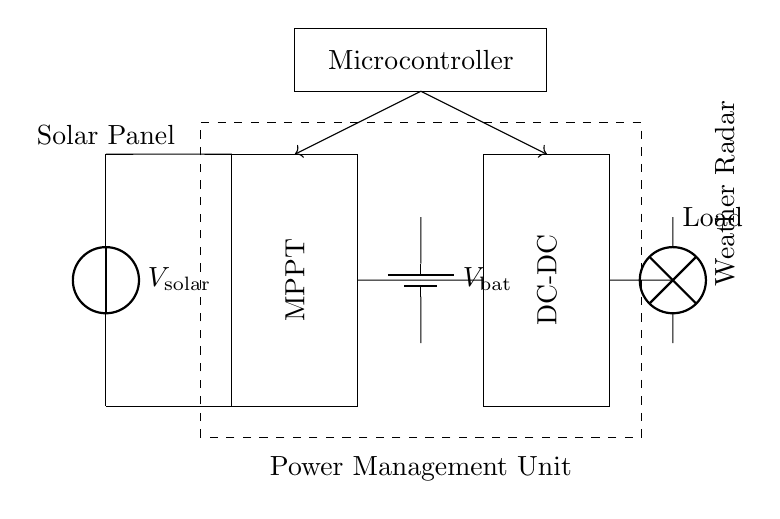What is the primary voltage source in this circuit? The primary voltage source is the solar panel, which is denoted as V_solar in the circuit. It converts sunlight into electrical energy to charge the battery.
Answer: V_solar What component manages the power flow from the solar panel? The component that manages the power flow from the solar panel is the MPPT, which stands for Maximum Power Point Tracking. It optimizes the energy harvested from the solar panel by adjusting the electrical operating point.
Answer: MPPT How many energy storage components are present in this circuit? The circuit contains one energy storage component, which is the battery labeled as V_bat. It stores energy for later use in the weather radar system.
Answer: One What is the role of the microcontroller in this circuit? The microcontroller's role is to control and manage the system's operations, including coordinating the solar panel, battery, and load based on the environmental conditions and power requirements.
Answer: Control What type of converter is used between the battery and the load? The type of converter used between the battery and the load is a DC-DC converter. This component steps up or steps down the voltage as necessary to ensure the weather radar receives the appropriate power level.
Answer: DC-DC Which element provides energy to the weather radar? The element that provides energy to the weather radar is the battery, which supplies stored electrical energy through the DC-DC converter and then to the load.
Answer: Battery What are the control lines used for in this circuit? The control lines, indicated by arrows from the microcontroller, are used for transmitting signals to control the operation of the MPPT and DC-DC converter to ensure efficient energy management.
Answer: Signals 